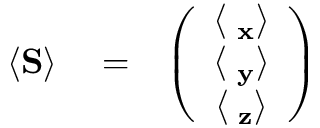Convert formula to latex. <formula><loc_0><loc_0><loc_500><loc_500>\begin{array} { r l r } { \langle { S } \rangle } & = } & { \left ( \begin{array} { c } { \langle { \sigma _ { x } } \rangle } \\ { \langle { \sigma _ { y } } \rangle } \\ { \langle { \sigma _ { z } } \rangle } \end{array} \right ) } \end{array}</formula> 